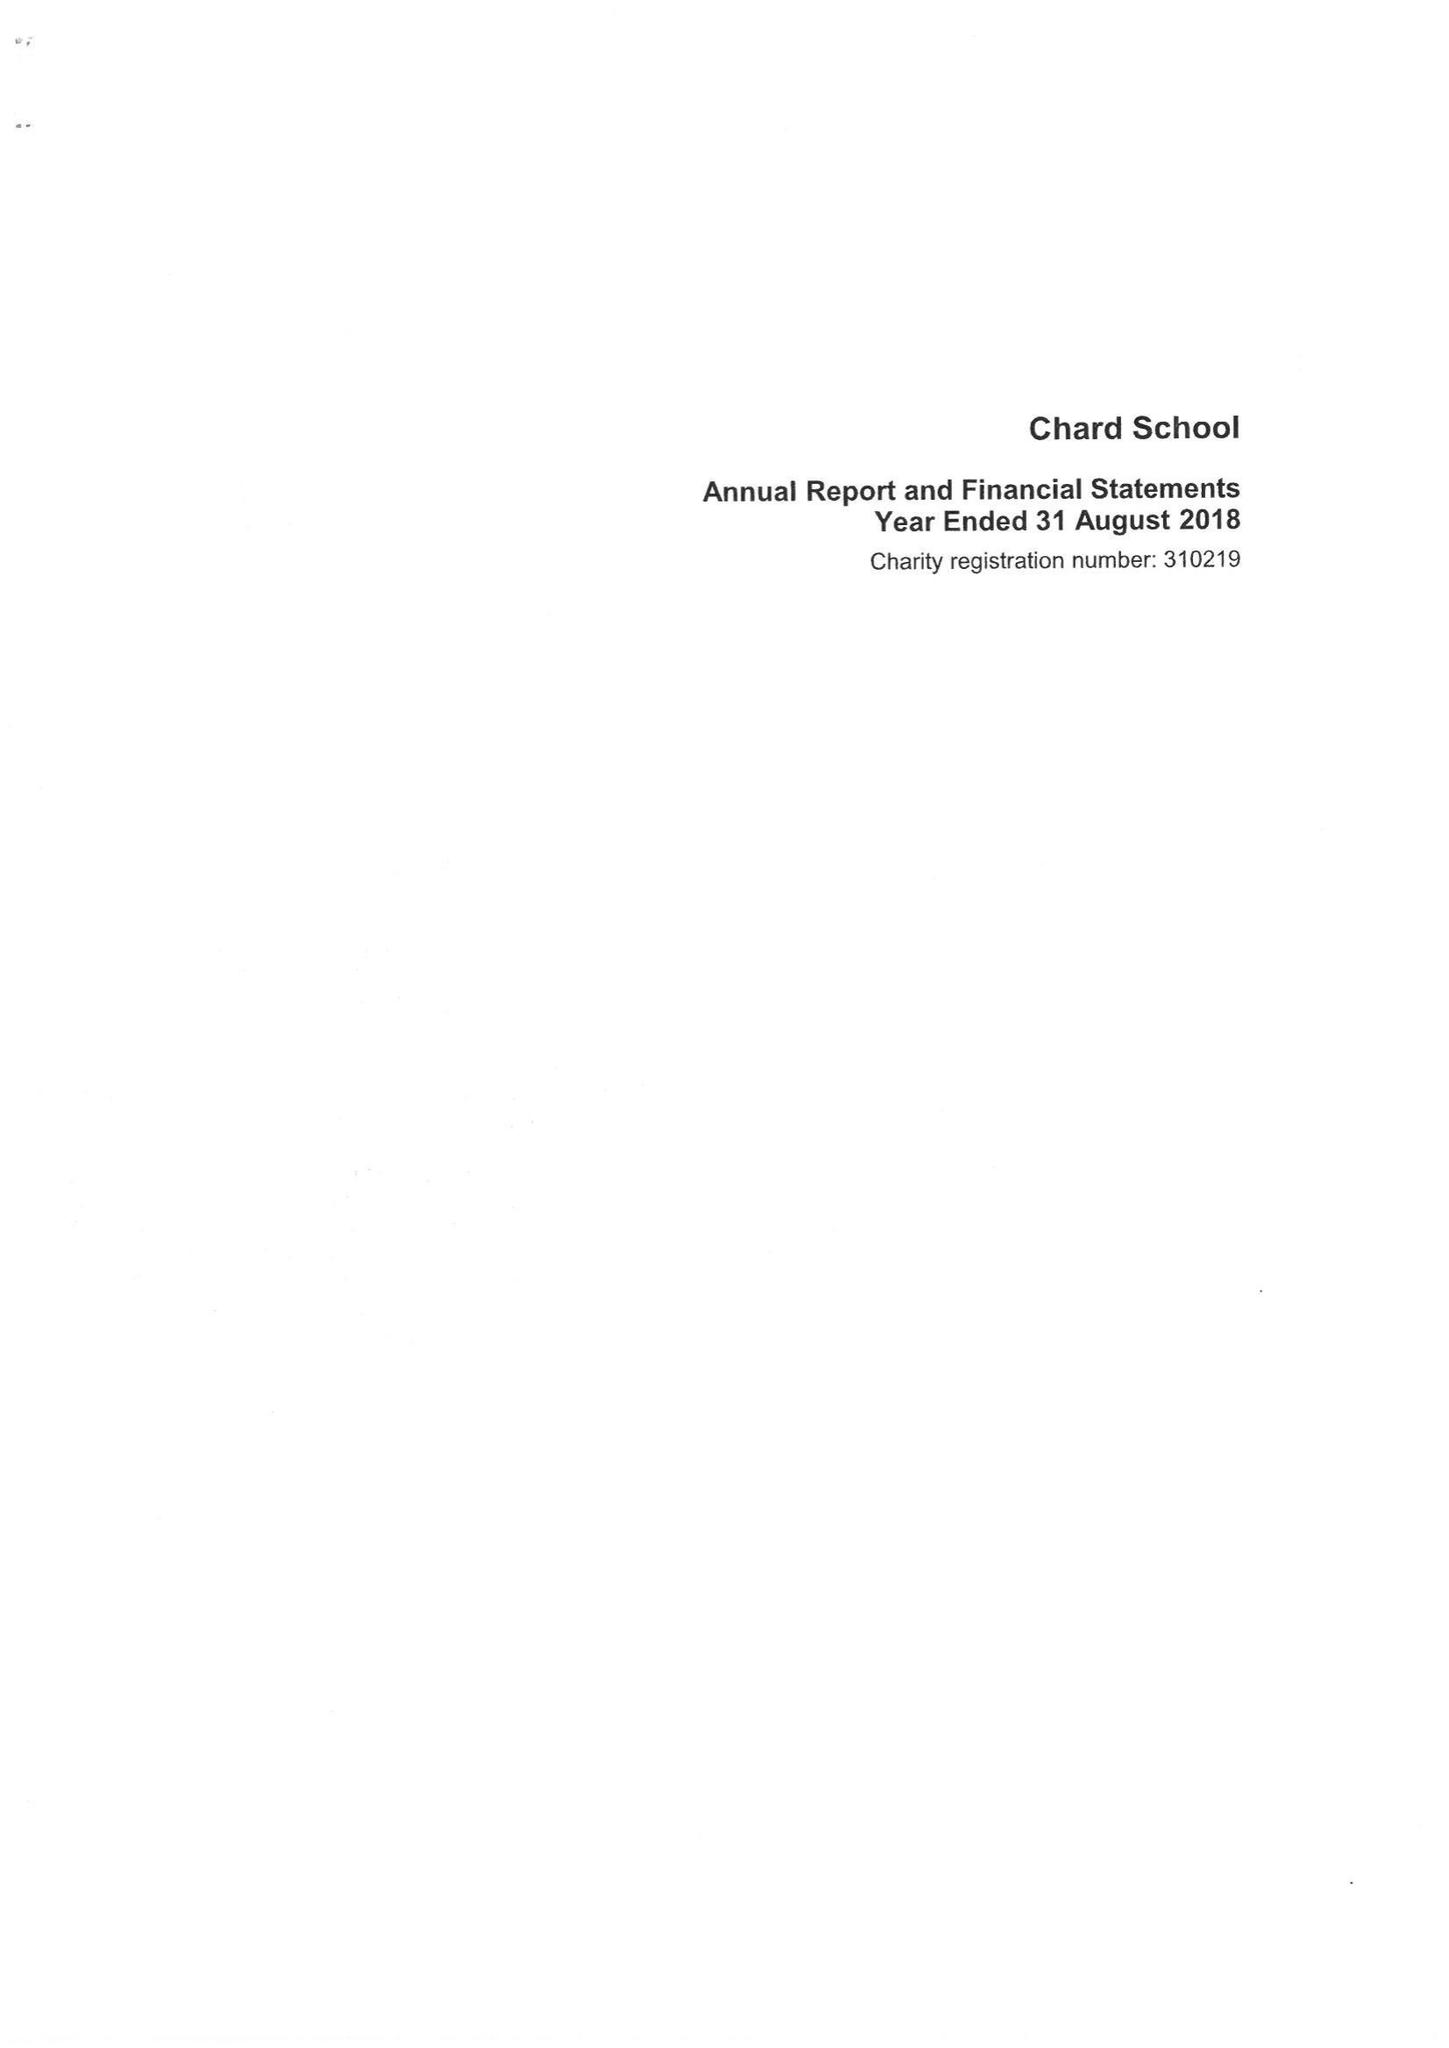What is the value for the address__post_town?
Answer the question using a single word or phrase. CHARD 